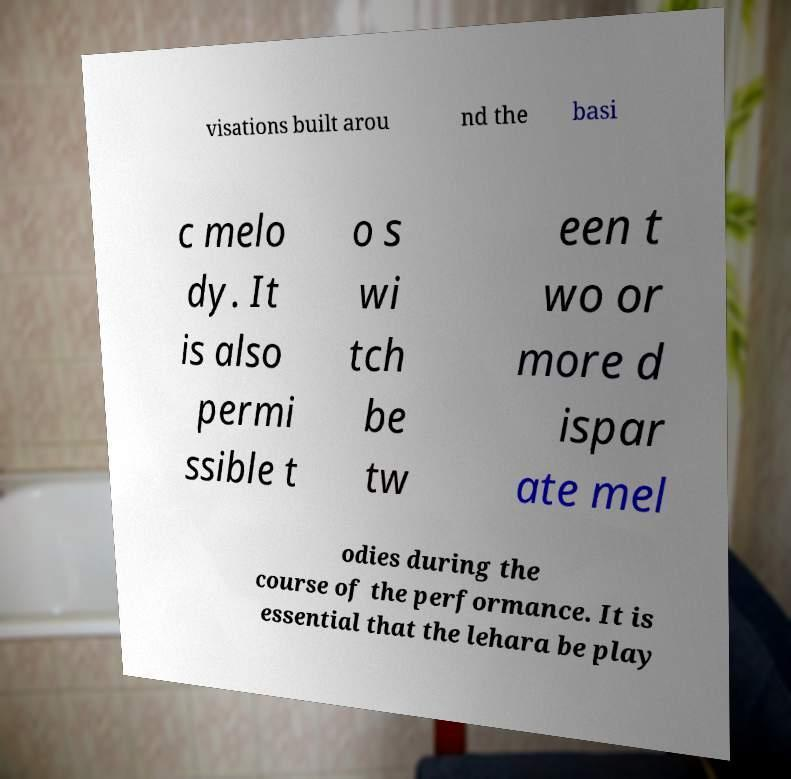Please read and relay the text visible in this image. What does it say? visations built arou nd the basi c melo dy. It is also permi ssible t o s wi tch be tw een t wo or more d ispar ate mel odies during the course of the performance. It is essential that the lehara be play 